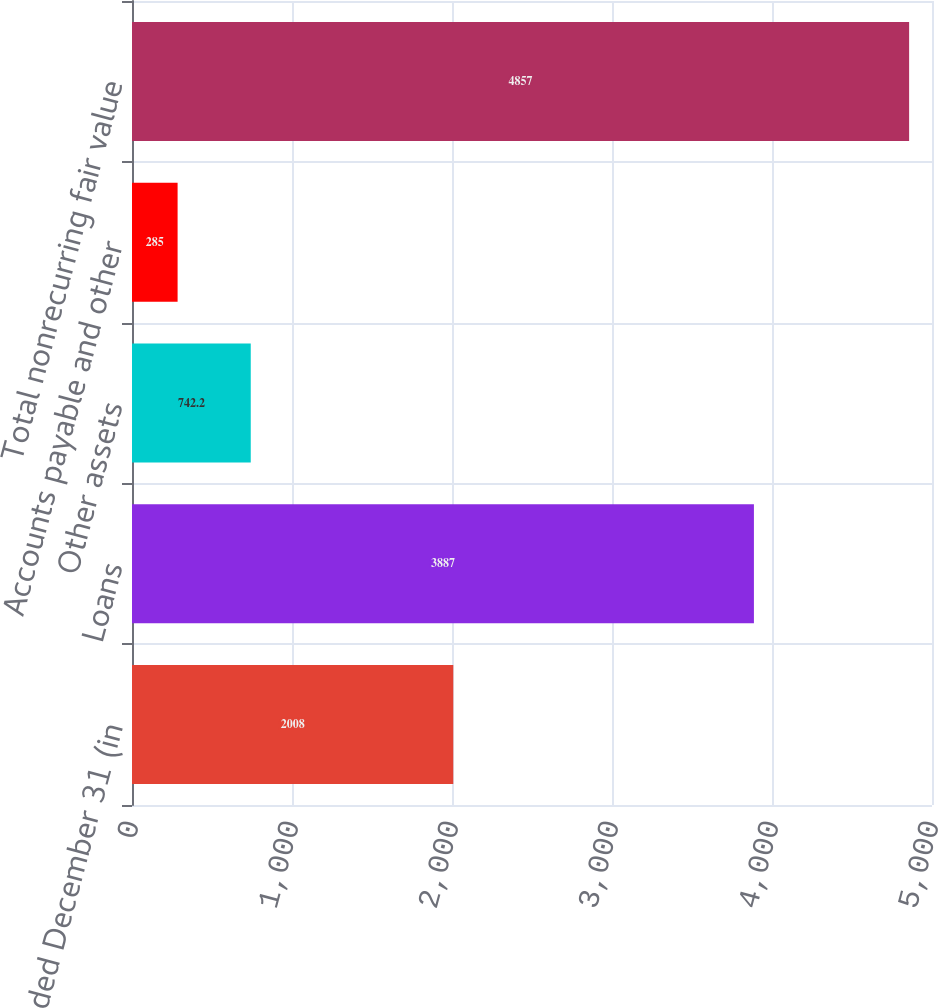Convert chart. <chart><loc_0><loc_0><loc_500><loc_500><bar_chart><fcel>Year ended December 31 (in<fcel>Loans<fcel>Other assets<fcel>Accounts payable and other<fcel>Total nonrecurring fair value<nl><fcel>2008<fcel>3887<fcel>742.2<fcel>285<fcel>4857<nl></chart> 